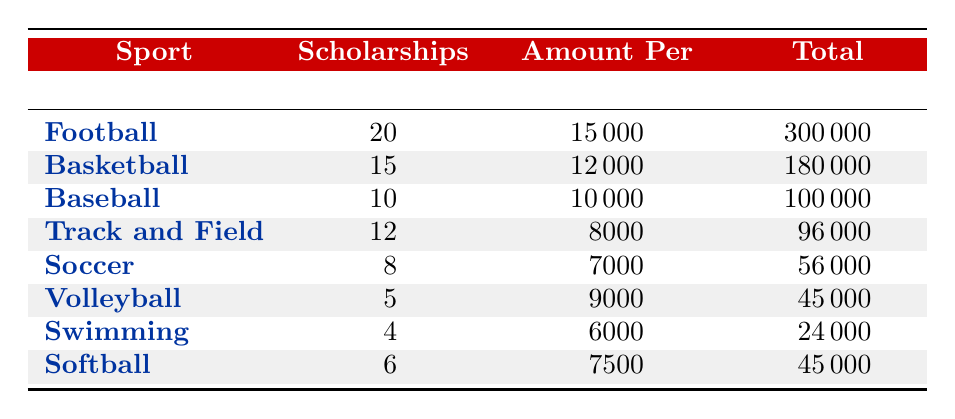What sport awarded the most scholarships? The sport with the highest number of scholarships awarded is Football, with 20 scholarships. This can be found in the first row of the table where Football is listed.
Answer: Football What is the total amount awarded for scholarships in Basketball? For Basketball, the total amount awarded is 180,000. This is directly stated in the row corresponding to Basketball in the Total column.
Answer: 180000 How many scholarships were awarded in total across all sports? To find the total number of scholarships awarded, we sum the values in the Scholarships Awarded column: 20 (Football) + 15 (Basketball) + 10 (Baseball) + 12 (Track and Field) + 8 (Soccer) + 5 (Volleyball) + 4 (Swimming) + 6 (Softball) = 80.
Answer: 80 Which sport has the highest amount per scholarship? The sport with the highest amount per scholarship is Football, which has 15,000 per scholarship. This is the highest value in the Amount Per Scholarship column.
Answer: Football Is the total amount awarded for Soccer greater than that of Softball? The total amount awarded for Soccer is 56,000, while for Softball it is 45,000. Since 56,000 is greater than 45,000, the statement is true.
Answer: Yes What is the average amount awarded across all sports per scholarship? To calculate the average amount awarded per scholarship, first sum the amounts awarded for each sport: 300,000 (Football) + 180,000 (Basketball) + 100,000 (Baseball) + 96,000 (Track and Field) + 56,000 (Soccer) + 45,000 (Volleyball) + 24,000 (Swimming) + 45,000 (Softball) = 826,000. Next, divide by the number of sports, which is 8, giving an average of 826,000 / 8 = 103,250.
Answer: 103250 Are there more scholarships awarded for Volleyball than Baseball? Volleyball has 5 scholarships awarded while Baseball has 10. Therefore, there are fewer scholarships awarded for Volleyball than Baseball, making the statement false.
Answer: No Which sport had the highest total amount awarded? Football had the highest total amount awarded of 300,000, compared to other sports. This can be identified as Football has the highest figure in the Total Amount column.
Answer: Football What is the difference in the total amount awarded between Football and Track and Field? The total for Football is 300,000, and for Track and Field, it is 96,000. The difference is calculated by subtracting: 300,000 - 96,000 = 204,000.
Answer: 204000 